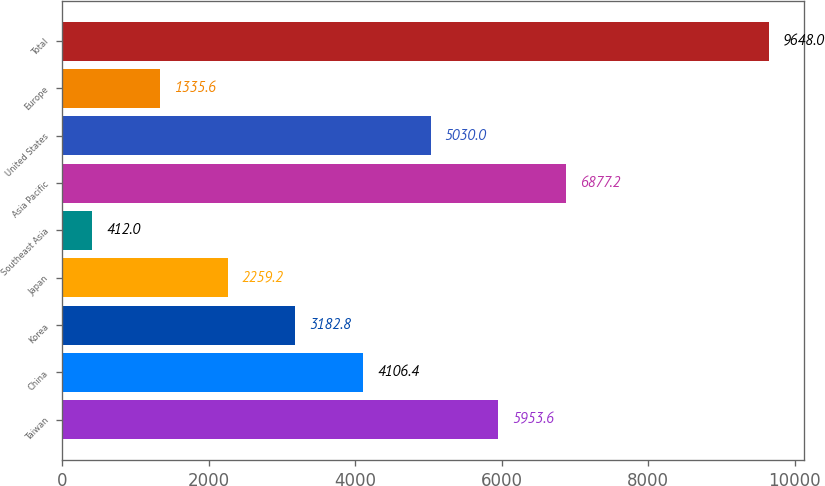Convert chart. <chart><loc_0><loc_0><loc_500><loc_500><bar_chart><fcel>Taiwan<fcel>China<fcel>Korea<fcel>Japan<fcel>Southeast Asia<fcel>Asia Pacific<fcel>United States<fcel>Europe<fcel>Total<nl><fcel>5953.6<fcel>4106.4<fcel>3182.8<fcel>2259.2<fcel>412<fcel>6877.2<fcel>5030<fcel>1335.6<fcel>9648<nl></chart> 